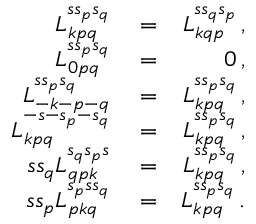<formula> <loc_0><loc_0><loc_500><loc_500>\begin{array} { r l r } { L _ { k p q } ^ { s s _ { p } s _ { q } } } & = } & { L _ { k q p } ^ { s s _ { q } s _ { p } } \, , } \\ { L _ { 0 p q } ^ { s s _ { p } s _ { q } } } & = } & { 0 \, , } \\ { L _ { - k - p - q } ^ { s s _ { p } s _ { q } } } & = } & { L _ { k p q } ^ { s s _ { p } s _ { q } } \, , } \\ { L _ { k p q } ^ { - s - s _ { p } - s _ { q } } } & = } & { L _ { k p q } ^ { s s _ { p } s _ { q } } \, , } \\ { s s _ { q } L _ { q p k } ^ { s _ { q } s _ { p } s } } & = } & { L _ { k p q } ^ { s s _ { p } s _ { q } } \, , } \\ { s s _ { p } L _ { p k q } ^ { s _ { p } s s _ { q } } } & = } & { L _ { k p q } ^ { s s _ { p } s _ { q } } \, . } \end{array}</formula> 